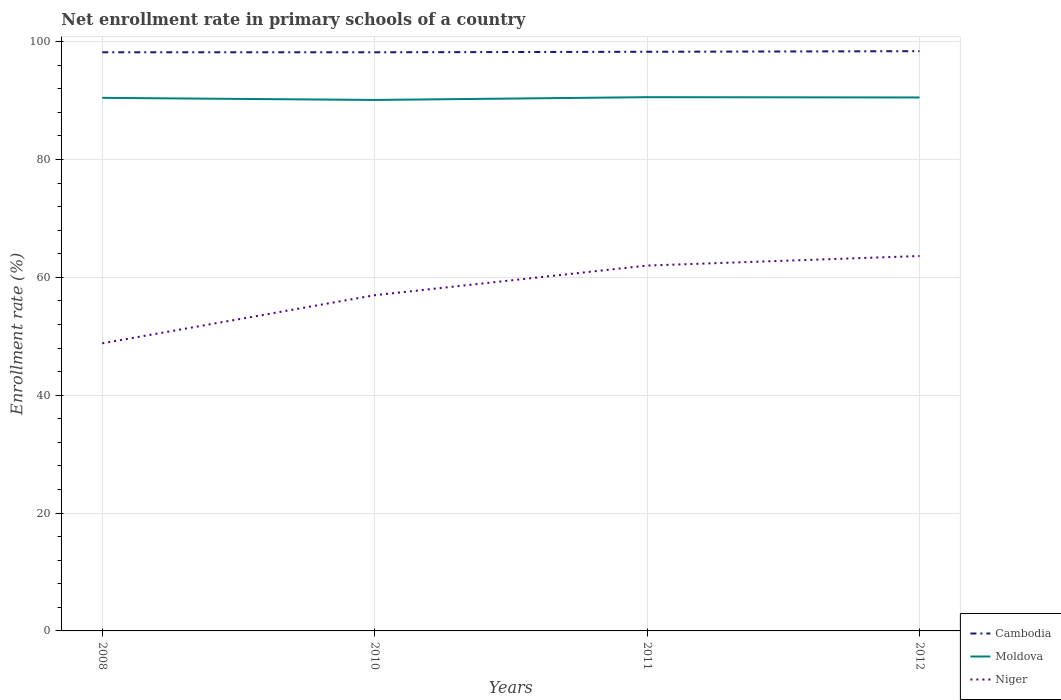Does the line corresponding to Cambodia intersect with the line corresponding to Niger?
Give a very brief answer. No. Across all years, what is the maximum enrollment rate in primary schools in Moldova?
Your answer should be compact. 90.11. In which year was the enrollment rate in primary schools in Moldova maximum?
Ensure brevity in your answer.  2010. What is the total enrollment rate in primary schools in Moldova in the graph?
Your response must be concise. -0.06. What is the difference between the highest and the second highest enrollment rate in primary schools in Moldova?
Provide a short and direct response. 0.47. What is the difference between the highest and the lowest enrollment rate in primary schools in Cambodia?
Provide a short and direct response. 2. How many years are there in the graph?
Provide a short and direct response. 4. Does the graph contain any zero values?
Your answer should be very brief. No. Does the graph contain grids?
Provide a succinct answer. Yes. How many legend labels are there?
Your answer should be compact. 3. What is the title of the graph?
Your response must be concise. Net enrollment rate in primary schools of a country. What is the label or title of the X-axis?
Keep it short and to the point. Years. What is the label or title of the Y-axis?
Provide a short and direct response. Enrollment rate (%). What is the Enrollment rate (%) of Cambodia in 2008?
Make the answer very short. 98.2. What is the Enrollment rate (%) in Moldova in 2008?
Keep it short and to the point. 90.46. What is the Enrollment rate (%) in Niger in 2008?
Give a very brief answer. 48.81. What is the Enrollment rate (%) of Cambodia in 2010?
Make the answer very short. 98.19. What is the Enrollment rate (%) of Moldova in 2010?
Your answer should be compact. 90.11. What is the Enrollment rate (%) in Niger in 2010?
Provide a succinct answer. 56.97. What is the Enrollment rate (%) of Cambodia in 2011?
Keep it short and to the point. 98.28. What is the Enrollment rate (%) of Moldova in 2011?
Offer a terse response. 90.58. What is the Enrollment rate (%) in Niger in 2011?
Ensure brevity in your answer.  62. What is the Enrollment rate (%) in Cambodia in 2012?
Your answer should be compact. 98.38. What is the Enrollment rate (%) in Moldova in 2012?
Make the answer very short. 90.53. What is the Enrollment rate (%) of Niger in 2012?
Provide a succinct answer. 63.62. Across all years, what is the maximum Enrollment rate (%) in Cambodia?
Make the answer very short. 98.38. Across all years, what is the maximum Enrollment rate (%) of Moldova?
Give a very brief answer. 90.58. Across all years, what is the maximum Enrollment rate (%) in Niger?
Offer a very short reply. 63.62. Across all years, what is the minimum Enrollment rate (%) of Cambodia?
Your answer should be very brief. 98.19. Across all years, what is the minimum Enrollment rate (%) in Moldova?
Offer a terse response. 90.11. Across all years, what is the minimum Enrollment rate (%) in Niger?
Keep it short and to the point. 48.81. What is the total Enrollment rate (%) of Cambodia in the graph?
Your response must be concise. 393.05. What is the total Enrollment rate (%) in Moldova in the graph?
Your response must be concise. 361.67. What is the total Enrollment rate (%) in Niger in the graph?
Ensure brevity in your answer.  231.4. What is the difference between the Enrollment rate (%) of Cambodia in 2008 and that in 2010?
Offer a very short reply. 0. What is the difference between the Enrollment rate (%) in Moldova in 2008 and that in 2010?
Give a very brief answer. 0.36. What is the difference between the Enrollment rate (%) in Niger in 2008 and that in 2010?
Keep it short and to the point. -8.16. What is the difference between the Enrollment rate (%) of Cambodia in 2008 and that in 2011?
Ensure brevity in your answer.  -0.09. What is the difference between the Enrollment rate (%) of Moldova in 2008 and that in 2011?
Offer a terse response. -0.11. What is the difference between the Enrollment rate (%) in Niger in 2008 and that in 2011?
Your answer should be compact. -13.2. What is the difference between the Enrollment rate (%) of Cambodia in 2008 and that in 2012?
Ensure brevity in your answer.  -0.19. What is the difference between the Enrollment rate (%) in Moldova in 2008 and that in 2012?
Your response must be concise. -0.06. What is the difference between the Enrollment rate (%) of Niger in 2008 and that in 2012?
Your answer should be compact. -14.81. What is the difference between the Enrollment rate (%) in Cambodia in 2010 and that in 2011?
Offer a very short reply. -0.09. What is the difference between the Enrollment rate (%) in Moldova in 2010 and that in 2011?
Keep it short and to the point. -0.47. What is the difference between the Enrollment rate (%) of Niger in 2010 and that in 2011?
Provide a short and direct response. -5.03. What is the difference between the Enrollment rate (%) in Cambodia in 2010 and that in 2012?
Give a very brief answer. -0.19. What is the difference between the Enrollment rate (%) in Moldova in 2010 and that in 2012?
Your answer should be very brief. -0.42. What is the difference between the Enrollment rate (%) in Niger in 2010 and that in 2012?
Offer a very short reply. -6.65. What is the difference between the Enrollment rate (%) in Cambodia in 2011 and that in 2012?
Your response must be concise. -0.1. What is the difference between the Enrollment rate (%) of Moldova in 2011 and that in 2012?
Keep it short and to the point. 0.05. What is the difference between the Enrollment rate (%) in Niger in 2011 and that in 2012?
Ensure brevity in your answer.  -1.62. What is the difference between the Enrollment rate (%) of Cambodia in 2008 and the Enrollment rate (%) of Moldova in 2010?
Provide a short and direct response. 8.09. What is the difference between the Enrollment rate (%) in Cambodia in 2008 and the Enrollment rate (%) in Niger in 2010?
Your answer should be very brief. 41.22. What is the difference between the Enrollment rate (%) in Moldova in 2008 and the Enrollment rate (%) in Niger in 2010?
Provide a short and direct response. 33.49. What is the difference between the Enrollment rate (%) of Cambodia in 2008 and the Enrollment rate (%) of Moldova in 2011?
Your response must be concise. 7.62. What is the difference between the Enrollment rate (%) in Cambodia in 2008 and the Enrollment rate (%) in Niger in 2011?
Your answer should be very brief. 36.19. What is the difference between the Enrollment rate (%) of Moldova in 2008 and the Enrollment rate (%) of Niger in 2011?
Your response must be concise. 28.46. What is the difference between the Enrollment rate (%) in Cambodia in 2008 and the Enrollment rate (%) in Moldova in 2012?
Provide a short and direct response. 7.67. What is the difference between the Enrollment rate (%) of Cambodia in 2008 and the Enrollment rate (%) of Niger in 2012?
Provide a short and direct response. 34.57. What is the difference between the Enrollment rate (%) in Moldova in 2008 and the Enrollment rate (%) in Niger in 2012?
Ensure brevity in your answer.  26.84. What is the difference between the Enrollment rate (%) in Cambodia in 2010 and the Enrollment rate (%) in Moldova in 2011?
Provide a succinct answer. 7.62. What is the difference between the Enrollment rate (%) in Cambodia in 2010 and the Enrollment rate (%) in Niger in 2011?
Keep it short and to the point. 36.19. What is the difference between the Enrollment rate (%) of Moldova in 2010 and the Enrollment rate (%) of Niger in 2011?
Provide a succinct answer. 28.1. What is the difference between the Enrollment rate (%) of Cambodia in 2010 and the Enrollment rate (%) of Moldova in 2012?
Ensure brevity in your answer.  7.67. What is the difference between the Enrollment rate (%) of Cambodia in 2010 and the Enrollment rate (%) of Niger in 2012?
Your answer should be compact. 34.57. What is the difference between the Enrollment rate (%) of Moldova in 2010 and the Enrollment rate (%) of Niger in 2012?
Offer a terse response. 26.48. What is the difference between the Enrollment rate (%) of Cambodia in 2011 and the Enrollment rate (%) of Moldova in 2012?
Keep it short and to the point. 7.75. What is the difference between the Enrollment rate (%) in Cambodia in 2011 and the Enrollment rate (%) in Niger in 2012?
Offer a terse response. 34.66. What is the difference between the Enrollment rate (%) in Moldova in 2011 and the Enrollment rate (%) in Niger in 2012?
Provide a succinct answer. 26.96. What is the average Enrollment rate (%) of Cambodia per year?
Give a very brief answer. 98.26. What is the average Enrollment rate (%) in Moldova per year?
Make the answer very short. 90.42. What is the average Enrollment rate (%) in Niger per year?
Provide a short and direct response. 57.85. In the year 2008, what is the difference between the Enrollment rate (%) in Cambodia and Enrollment rate (%) in Moldova?
Your answer should be very brief. 7.73. In the year 2008, what is the difference between the Enrollment rate (%) of Cambodia and Enrollment rate (%) of Niger?
Keep it short and to the point. 49.39. In the year 2008, what is the difference between the Enrollment rate (%) in Moldova and Enrollment rate (%) in Niger?
Provide a short and direct response. 41.66. In the year 2010, what is the difference between the Enrollment rate (%) in Cambodia and Enrollment rate (%) in Moldova?
Your response must be concise. 8.09. In the year 2010, what is the difference between the Enrollment rate (%) of Cambodia and Enrollment rate (%) of Niger?
Give a very brief answer. 41.22. In the year 2010, what is the difference between the Enrollment rate (%) in Moldova and Enrollment rate (%) in Niger?
Your answer should be very brief. 33.13. In the year 2011, what is the difference between the Enrollment rate (%) of Cambodia and Enrollment rate (%) of Moldova?
Your answer should be very brief. 7.7. In the year 2011, what is the difference between the Enrollment rate (%) of Cambodia and Enrollment rate (%) of Niger?
Keep it short and to the point. 36.28. In the year 2011, what is the difference between the Enrollment rate (%) in Moldova and Enrollment rate (%) in Niger?
Your answer should be compact. 28.58. In the year 2012, what is the difference between the Enrollment rate (%) of Cambodia and Enrollment rate (%) of Moldova?
Give a very brief answer. 7.85. In the year 2012, what is the difference between the Enrollment rate (%) of Cambodia and Enrollment rate (%) of Niger?
Provide a succinct answer. 34.76. In the year 2012, what is the difference between the Enrollment rate (%) in Moldova and Enrollment rate (%) in Niger?
Ensure brevity in your answer.  26.91. What is the ratio of the Enrollment rate (%) of Cambodia in 2008 to that in 2010?
Your answer should be very brief. 1. What is the ratio of the Enrollment rate (%) of Niger in 2008 to that in 2010?
Your answer should be compact. 0.86. What is the ratio of the Enrollment rate (%) in Moldova in 2008 to that in 2011?
Your response must be concise. 1. What is the ratio of the Enrollment rate (%) of Niger in 2008 to that in 2011?
Your answer should be very brief. 0.79. What is the ratio of the Enrollment rate (%) of Moldova in 2008 to that in 2012?
Your answer should be very brief. 1. What is the ratio of the Enrollment rate (%) in Niger in 2008 to that in 2012?
Keep it short and to the point. 0.77. What is the ratio of the Enrollment rate (%) in Cambodia in 2010 to that in 2011?
Your answer should be very brief. 1. What is the ratio of the Enrollment rate (%) of Moldova in 2010 to that in 2011?
Provide a short and direct response. 0.99. What is the ratio of the Enrollment rate (%) in Niger in 2010 to that in 2011?
Your answer should be compact. 0.92. What is the ratio of the Enrollment rate (%) of Moldova in 2010 to that in 2012?
Your answer should be very brief. 1. What is the ratio of the Enrollment rate (%) in Niger in 2010 to that in 2012?
Provide a short and direct response. 0.9. What is the ratio of the Enrollment rate (%) in Cambodia in 2011 to that in 2012?
Provide a short and direct response. 1. What is the ratio of the Enrollment rate (%) in Niger in 2011 to that in 2012?
Keep it short and to the point. 0.97. What is the difference between the highest and the second highest Enrollment rate (%) in Cambodia?
Keep it short and to the point. 0.1. What is the difference between the highest and the second highest Enrollment rate (%) in Moldova?
Offer a terse response. 0.05. What is the difference between the highest and the second highest Enrollment rate (%) in Niger?
Your answer should be very brief. 1.62. What is the difference between the highest and the lowest Enrollment rate (%) in Cambodia?
Offer a terse response. 0.19. What is the difference between the highest and the lowest Enrollment rate (%) of Moldova?
Your response must be concise. 0.47. What is the difference between the highest and the lowest Enrollment rate (%) in Niger?
Keep it short and to the point. 14.81. 